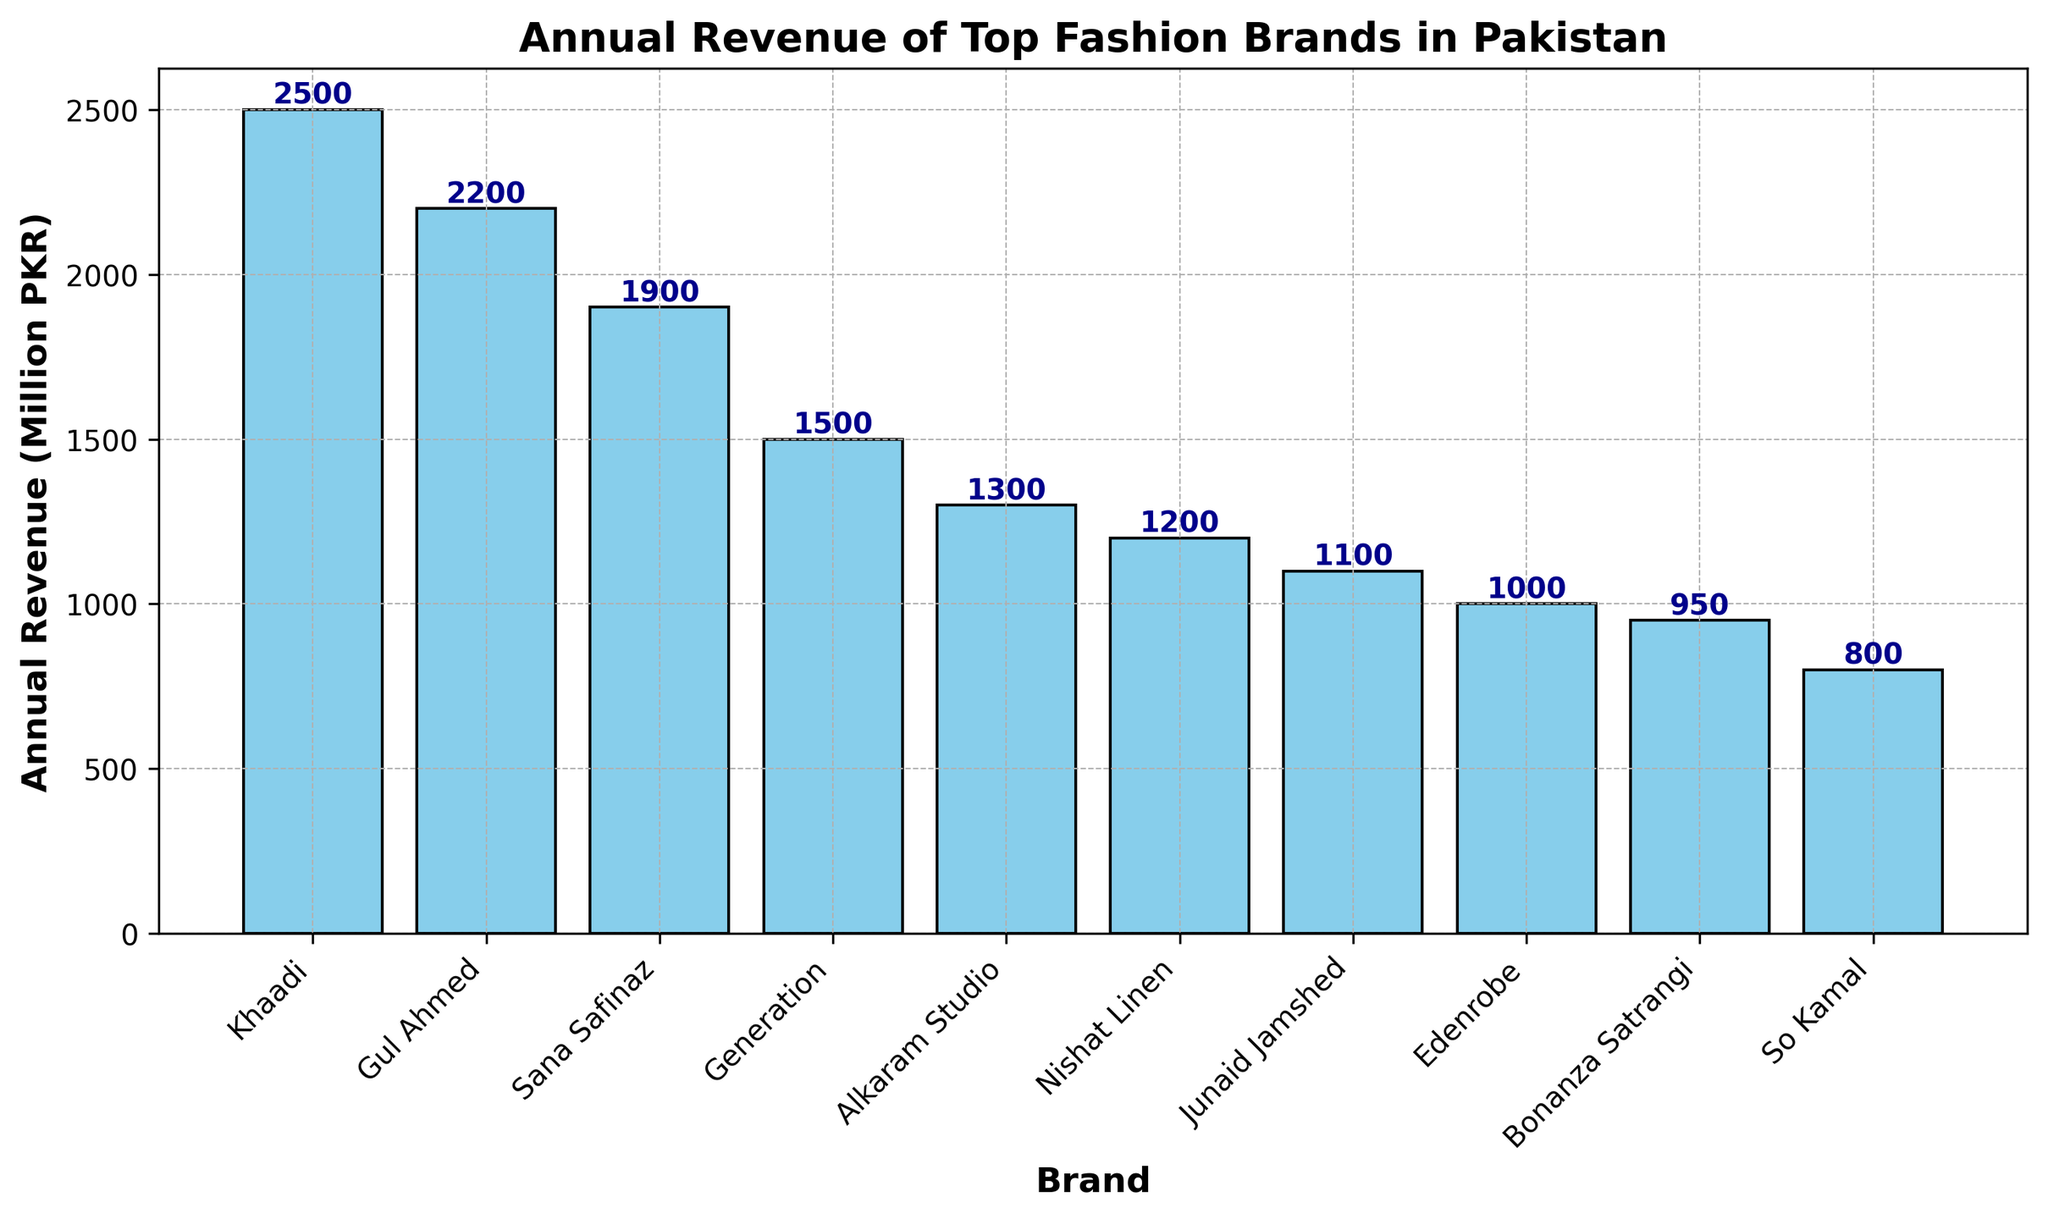Which brand has the highest annual revenue? The bar chart shows the annual revenue for each fashion brand in Pakistan by the height of the bars. The tallest bar represents Khaadi, which has the highest annual revenue.
Answer: Khaadi Which two brands have a combined annual revenue of 4100 Million PKR? To find this, look for two bars whose heights sum up to 4100 Million PKR. Khaadi has 2500 Million PKR, and Gul Ahmed has 2200 Million PKR. 2500 + 1600 = 4100.
Answer: Khaadi and Sana Safinaz What is the difference in annual revenue between Alkaram Studio and Bonanza Satrangi? Identify the bars for Alkaram Studio and Bonanza Satrangi. Alkaram Studio has 1300 Million PKR and Bonanza Satrangi has 950 Million PKR. The difference is 1300 - 950.
Answer: 350 Million PKR Which brand has the lowest annual revenue? Among the bars in the chart, the shortest one represents the brand with the lowest annual revenue. So Kamal is the shortest bar with 800 Million PKR.
Answer: So Kamal How much more revenue does Khaadi generate compared to Generation? Find the bars for Khaadi and Generation. Khaadi has 2500 Million PKR and Generation has 1500 Million PKR. The difference is 2500 - 1500.
Answer: 1000 Million PKR List the brands with an annual revenue greater than 1500 Million PKR. Look for bars higher than 1500 on the y-axis. Khaadi (2500), Gul Ahmed (2200), and Sana Safinaz (1900) all have revenues greater than 1500.
Answer: Khaadi, Gul Ahmed, Sana Safinaz What is the median annual revenue among the top fashion brands listed? First, list all the revenues in order: 800, 950, 1000, 1100, 1200, 1300, 1500, 1900, 2200, 2500. The middle value (5th and 6th when averaged) is (1300 + 1500) / 2.
Answer: 1400 Million PKR What is the total annual revenue of all the brands combined? Add up all the revenue figures from the bars. 2500 + 2200 + 1900 + 1500 + 1300 + 1200 + 1100 + 1000 + 950 + 800 = 14450 Million PKR.
Answer: 14450 Million PKR 